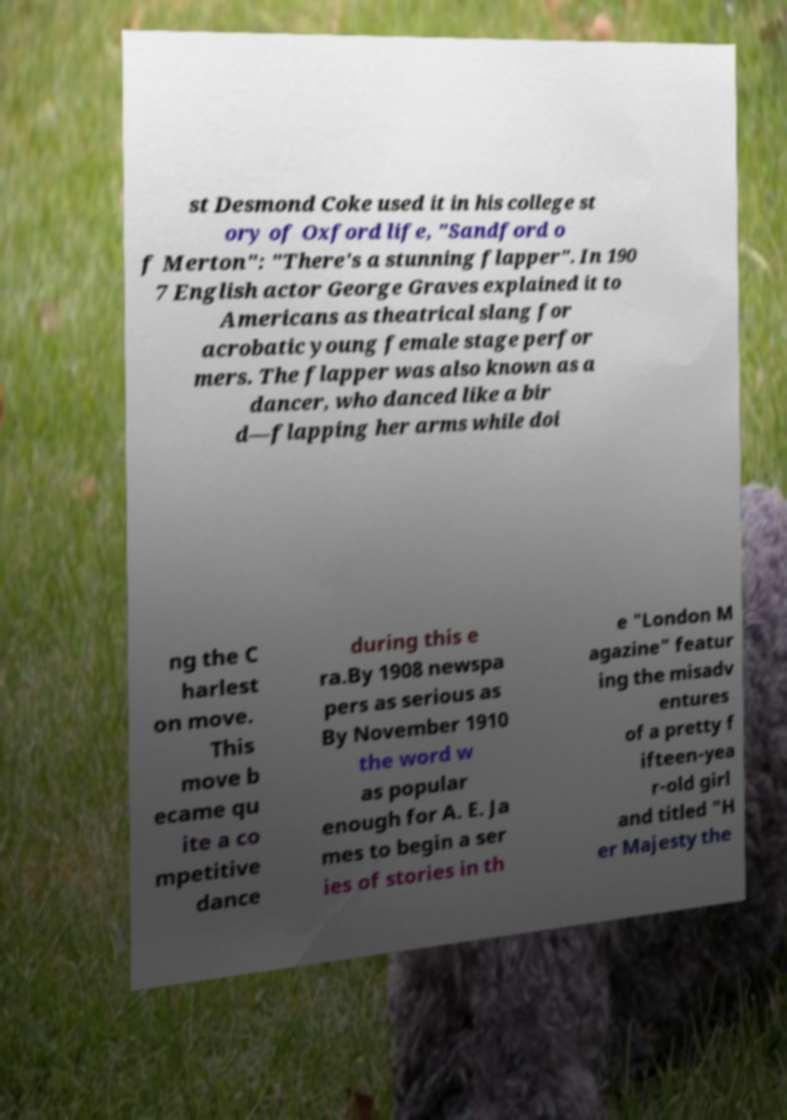Can you accurately transcribe the text from the provided image for me? st Desmond Coke used it in his college st ory of Oxford life, "Sandford o f Merton": "There's a stunning flapper". In 190 7 English actor George Graves explained it to Americans as theatrical slang for acrobatic young female stage perfor mers. The flapper was also known as a dancer, who danced like a bir d—flapping her arms while doi ng the C harlest on move. This move b ecame qu ite a co mpetitive dance during this e ra.By 1908 newspa pers as serious as By November 1910 the word w as popular enough for A. E. Ja mes to begin a ser ies of stories in th e "London M agazine" featur ing the misadv entures of a pretty f ifteen-yea r-old girl and titled "H er Majesty the 